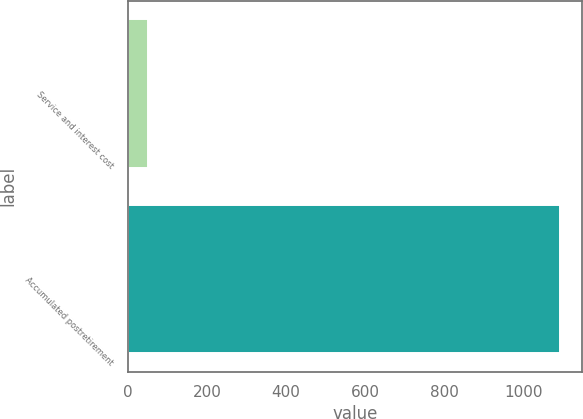Convert chart. <chart><loc_0><loc_0><loc_500><loc_500><bar_chart><fcel>Service and interest cost<fcel>Accumulated postretirement<nl><fcel>50<fcel>1094<nl></chart> 